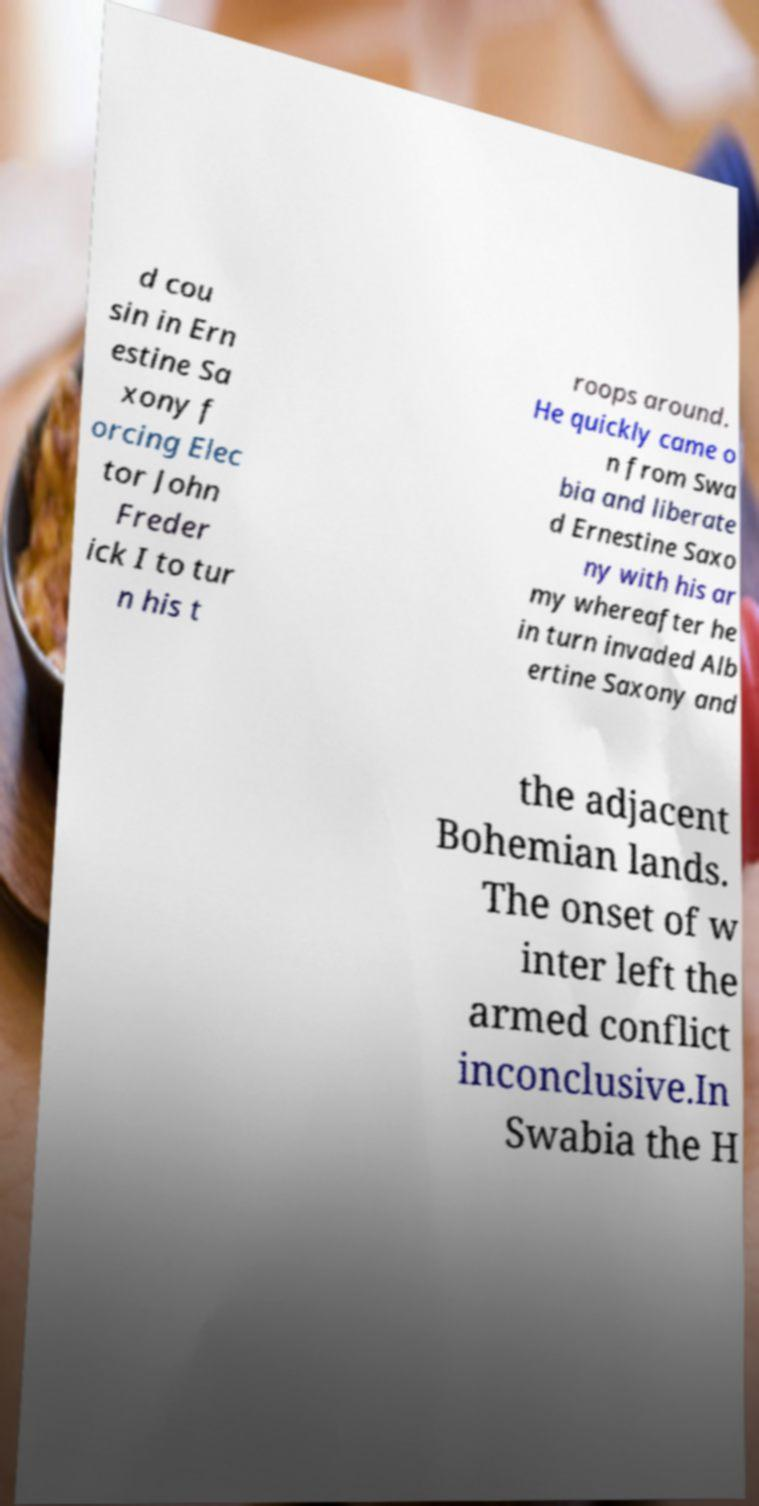Could you assist in decoding the text presented in this image and type it out clearly? d cou sin in Ern estine Sa xony f orcing Elec tor John Freder ick I to tur n his t roops around. He quickly came o n from Swa bia and liberate d Ernestine Saxo ny with his ar my whereafter he in turn invaded Alb ertine Saxony and the adjacent Bohemian lands. The onset of w inter left the armed conflict inconclusive.In Swabia the H 